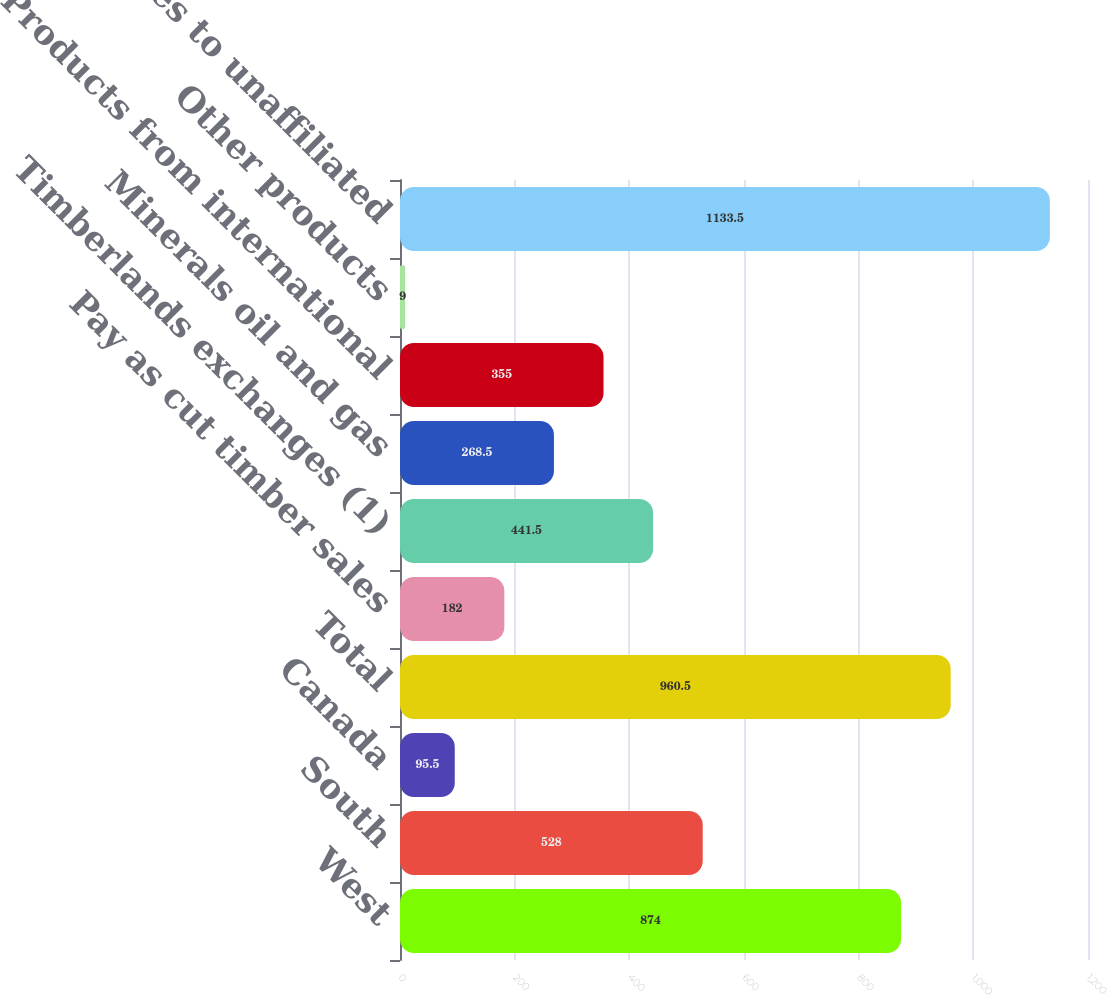Convert chart to OTSL. <chart><loc_0><loc_0><loc_500><loc_500><bar_chart><fcel>West<fcel>South<fcel>Canada<fcel>Total<fcel>Pay as cut timber sales<fcel>Timberlands exchanges (1)<fcel>Minerals oil and gas<fcel>Products from international<fcel>Other products<fcel>Subtotal sales to unaffiliated<nl><fcel>874<fcel>528<fcel>95.5<fcel>960.5<fcel>182<fcel>441.5<fcel>268.5<fcel>355<fcel>9<fcel>1133.5<nl></chart> 